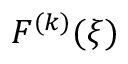<formula> <loc_0><loc_0><loc_500><loc_500>F ^ { ( k ) } ( \xi )</formula> 